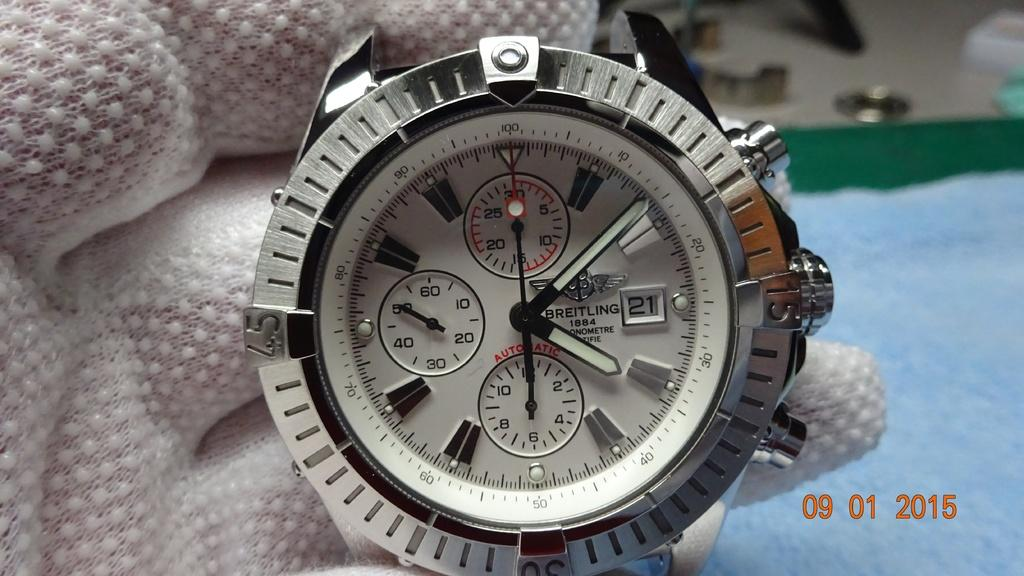<image>
Relay a brief, clear account of the picture shown. White and silver watch which has the word BREITLING on the face. 